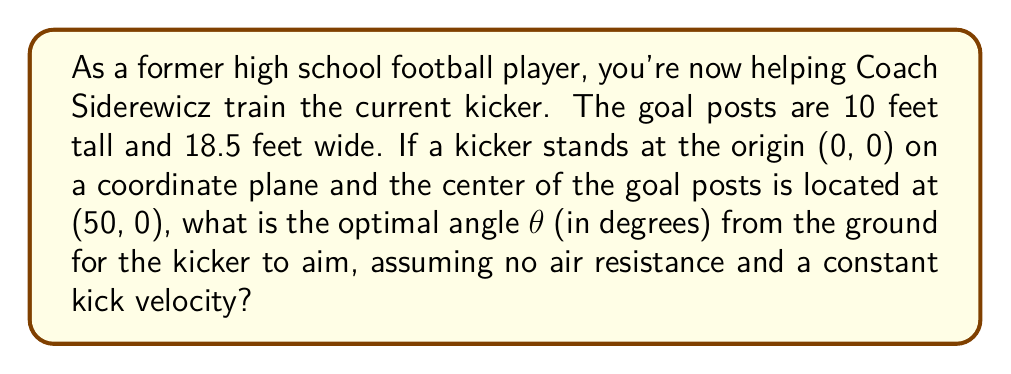Help me with this question. Let's approach this step-by-step:

1) First, we need to determine the coordinates of the top center of the goal posts. We know that:
   - The center of the goal posts is at (50, 0)
   - The goal posts are 10 feet tall

   So, the top center of the goal posts is at (50, 10)

2) Now, we can use trigonometry to find the angle. We'll use the tangent function:

   $$\tan θ = \frac{\text{opposite}}{\text{adjacent}} = \frac{\text{height}}{\text{distance}}$$

3) In our case:
   - The height (opposite) is 10 feet
   - The distance (adjacent) is 50 feet

4) Plugging these into our equation:

   $$\tan θ = \frac{10}{50} = \frac{1}{5} = 0.2$$

5) To find θ, we need to use the inverse tangent (arctan or tan^(-1)):

   $$θ = \tan^{-1}(0.2)$$

6) Using a calculator or trigonometric tables:

   $$θ ≈ 11.3099325°$$

7) Rounding to two decimal places:

   $$θ ≈ 11.31°$$

This angle provides the optimal trajectory for the kick, assuming no external factors like wind or air resistance.

[asy]
import geometry;

size(200);
draw((0,0)--(60,0), arrow=Arrow(TeXHead));
draw((0,0)--(0,15), arrow=Arrow(TeXHead));
draw((0,0)--(50,10), arrow=Arrow(TeXHead));
draw((50,0)--(50,10));

label("x", (60,0), E);
label("y", (0,15), N);
label("(50, 10)", (50,10), NE);
label("(0, 0)", (0,0), SW);
label("θ", (5,1), NW);

dot((0,0));
dot((50,10));
[/asy]
Answer: 11.31° 